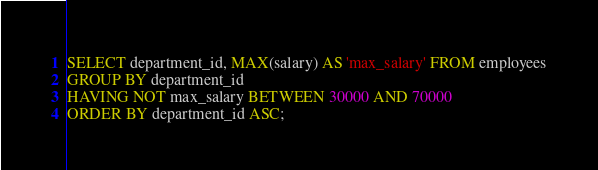Convert code to text. <code><loc_0><loc_0><loc_500><loc_500><_SQL_>SELECT department_id, MAX(salary) AS 'max_salary' FROM employees
GROUP BY department_id
HAVING NOT max_salary BETWEEN 30000 AND 70000
ORDER BY department_id ASC;</code> 